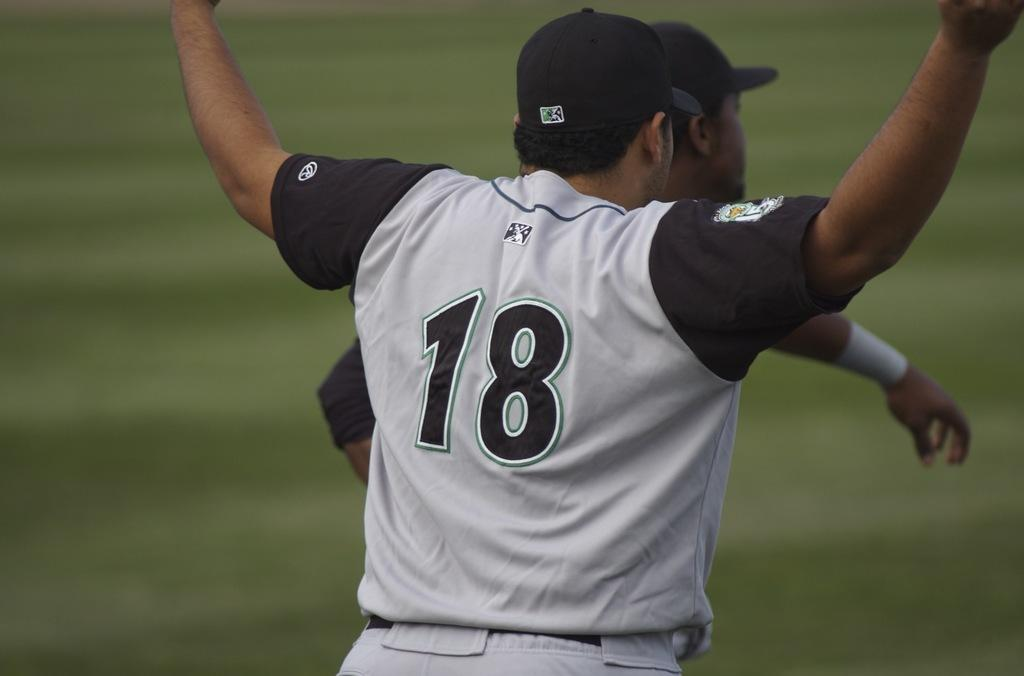Provide a one-sentence caption for the provided image. The baseball player holding up his arms has the number 18 on his jersey. 